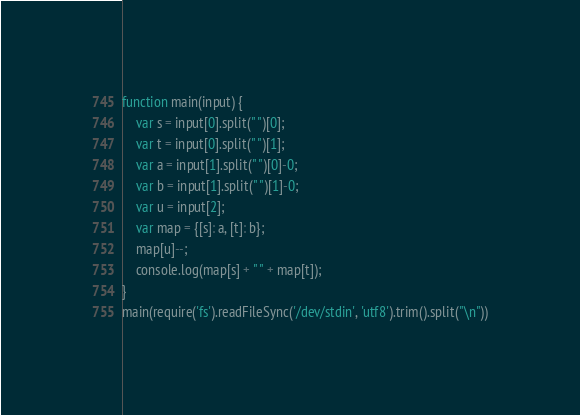Convert code to text. <code><loc_0><loc_0><loc_500><loc_500><_JavaScript_>function main(input) {
    var s = input[0].split(" ")[0];
    var t = input[0].split(" ")[1];
    var a = input[1].split(" ")[0]-0;
    var b = input[1].split(" ")[1]-0;
    var u = input[2];
    var map = {[s]: a, [t]: b};
    map[u]--;
    console.log(map[s] + " " + map[t]);
}
main(require('fs').readFileSync('/dev/stdin', 'utf8').trim().split("\n"))
</code> 